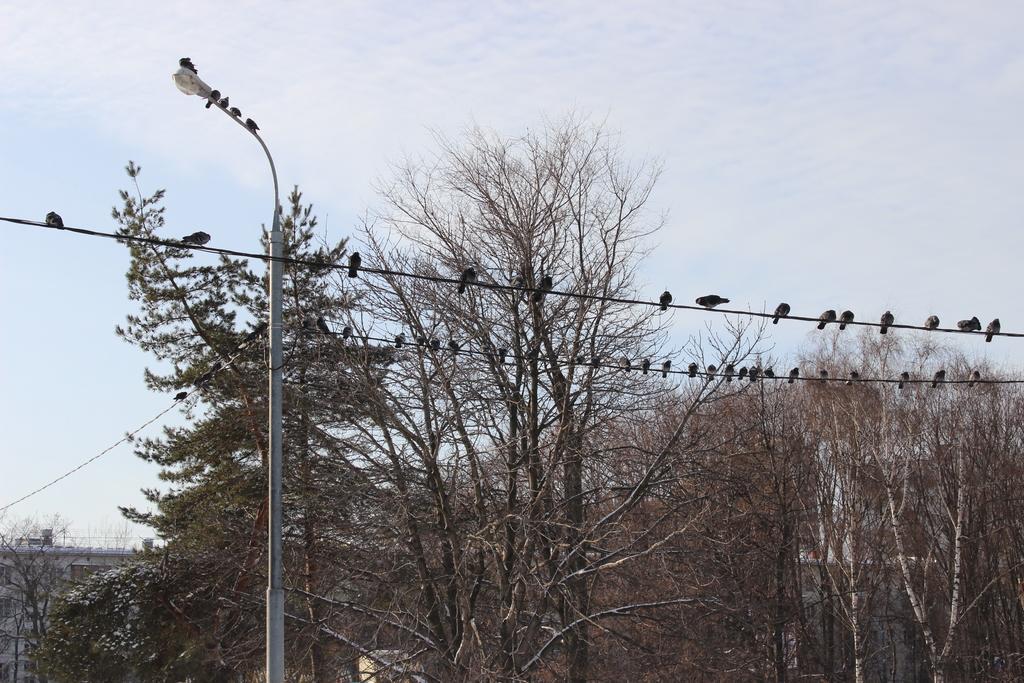Can you describe this image briefly? In this picture there is a pole on the left side of the image and there are wires at the top side of the image, there are birds on the wires and there are trees in the image. 